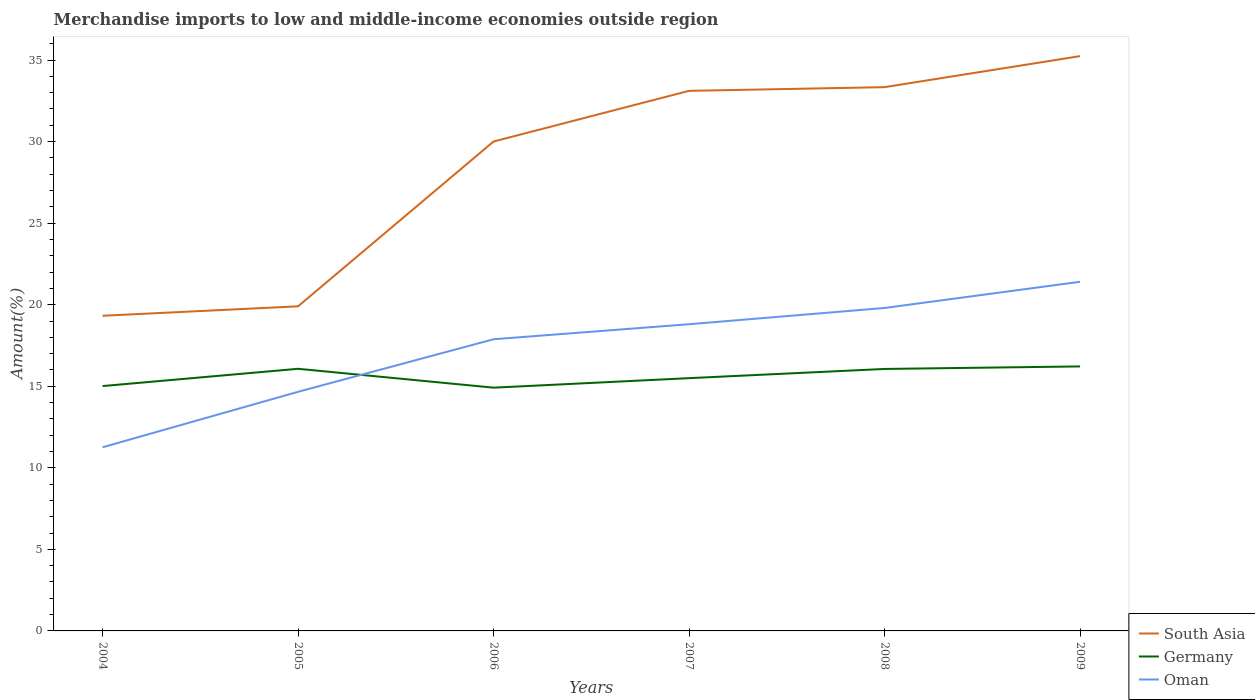Across all years, what is the maximum percentage of amount earned from merchandise imports in South Asia?
Give a very brief answer. 19.32. In which year was the percentage of amount earned from merchandise imports in Oman maximum?
Give a very brief answer. 2004. What is the total percentage of amount earned from merchandise imports in Germany in the graph?
Provide a short and direct response. 0.1. What is the difference between the highest and the second highest percentage of amount earned from merchandise imports in Oman?
Provide a short and direct response. 10.15. What is the difference between the highest and the lowest percentage of amount earned from merchandise imports in Germany?
Give a very brief answer. 3. What is the difference between two consecutive major ticks on the Y-axis?
Ensure brevity in your answer.  5. Does the graph contain any zero values?
Keep it short and to the point. No. Does the graph contain grids?
Your response must be concise. No. How many legend labels are there?
Offer a very short reply. 3. How are the legend labels stacked?
Give a very brief answer. Vertical. What is the title of the graph?
Your answer should be compact. Merchandise imports to low and middle-income economies outside region. What is the label or title of the X-axis?
Make the answer very short. Years. What is the label or title of the Y-axis?
Offer a terse response. Amount(%). What is the Amount(%) in South Asia in 2004?
Keep it short and to the point. 19.32. What is the Amount(%) in Germany in 2004?
Your answer should be very brief. 15.01. What is the Amount(%) of Oman in 2004?
Your answer should be very brief. 11.26. What is the Amount(%) in South Asia in 2005?
Give a very brief answer. 19.9. What is the Amount(%) of Germany in 2005?
Offer a very short reply. 16.07. What is the Amount(%) of Oman in 2005?
Keep it short and to the point. 14.66. What is the Amount(%) in South Asia in 2006?
Your response must be concise. 30.01. What is the Amount(%) of Germany in 2006?
Your response must be concise. 14.91. What is the Amount(%) in Oman in 2006?
Provide a short and direct response. 17.88. What is the Amount(%) in South Asia in 2007?
Make the answer very short. 33.11. What is the Amount(%) in Germany in 2007?
Ensure brevity in your answer.  15.5. What is the Amount(%) of Oman in 2007?
Give a very brief answer. 18.8. What is the Amount(%) in South Asia in 2008?
Provide a succinct answer. 33.34. What is the Amount(%) in Germany in 2008?
Your answer should be very brief. 16.06. What is the Amount(%) of Oman in 2008?
Offer a terse response. 19.8. What is the Amount(%) of South Asia in 2009?
Offer a terse response. 35.24. What is the Amount(%) in Germany in 2009?
Make the answer very short. 16.22. What is the Amount(%) of Oman in 2009?
Provide a succinct answer. 21.41. Across all years, what is the maximum Amount(%) of South Asia?
Ensure brevity in your answer.  35.24. Across all years, what is the maximum Amount(%) of Germany?
Keep it short and to the point. 16.22. Across all years, what is the maximum Amount(%) in Oman?
Keep it short and to the point. 21.41. Across all years, what is the minimum Amount(%) of South Asia?
Keep it short and to the point. 19.32. Across all years, what is the minimum Amount(%) in Germany?
Your response must be concise. 14.91. Across all years, what is the minimum Amount(%) of Oman?
Make the answer very short. 11.26. What is the total Amount(%) in South Asia in the graph?
Give a very brief answer. 170.92. What is the total Amount(%) of Germany in the graph?
Ensure brevity in your answer.  93.77. What is the total Amount(%) in Oman in the graph?
Offer a very short reply. 103.81. What is the difference between the Amount(%) in South Asia in 2004 and that in 2005?
Provide a short and direct response. -0.58. What is the difference between the Amount(%) of Germany in 2004 and that in 2005?
Keep it short and to the point. -1.06. What is the difference between the Amount(%) in Oman in 2004 and that in 2005?
Keep it short and to the point. -3.4. What is the difference between the Amount(%) of South Asia in 2004 and that in 2006?
Provide a succinct answer. -10.68. What is the difference between the Amount(%) of Germany in 2004 and that in 2006?
Ensure brevity in your answer.  0.1. What is the difference between the Amount(%) in Oman in 2004 and that in 2006?
Offer a very short reply. -6.62. What is the difference between the Amount(%) in South Asia in 2004 and that in 2007?
Give a very brief answer. -13.79. What is the difference between the Amount(%) of Germany in 2004 and that in 2007?
Your response must be concise. -0.49. What is the difference between the Amount(%) in Oman in 2004 and that in 2007?
Offer a very short reply. -7.54. What is the difference between the Amount(%) of South Asia in 2004 and that in 2008?
Your response must be concise. -14.02. What is the difference between the Amount(%) in Germany in 2004 and that in 2008?
Provide a succinct answer. -1.05. What is the difference between the Amount(%) in Oman in 2004 and that in 2008?
Your answer should be compact. -8.54. What is the difference between the Amount(%) in South Asia in 2004 and that in 2009?
Provide a short and direct response. -15.92. What is the difference between the Amount(%) of Germany in 2004 and that in 2009?
Your answer should be very brief. -1.2. What is the difference between the Amount(%) in Oman in 2004 and that in 2009?
Keep it short and to the point. -10.15. What is the difference between the Amount(%) in South Asia in 2005 and that in 2006?
Your answer should be compact. -10.1. What is the difference between the Amount(%) of Germany in 2005 and that in 2006?
Provide a succinct answer. 1.16. What is the difference between the Amount(%) of Oman in 2005 and that in 2006?
Provide a succinct answer. -3.22. What is the difference between the Amount(%) in South Asia in 2005 and that in 2007?
Your response must be concise. -13.21. What is the difference between the Amount(%) in Germany in 2005 and that in 2007?
Make the answer very short. 0.57. What is the difference between the Amount(%) of Oman in 2005 and that in 2007?
Your answer should be very brief. -4.14. What is the difference between the Amount(%) in South Asia in 2005 and that in 2008?
Your answer should be compact. -13.44. What is the difference between the Amount(%) of Germany in 2005 and that in 2008?
Provide a succinct answer. 0.01. What is the difference between the Amount(%) of Oman in 2005 and that in 2008?
Your answer should be compact. -5.14. What is the difference between the Amount(%) of South Asia in 2005 and that in 2009?
Keep it short and to the point. -15.34. What is the difference between the Amount(%) of Germany in 2005 and that in 2009?
Ensure brevity in your answer.  -0.15. What is the difference between the Amount(%) of Oman in 2005 and that in 2009?
Your response must be concise. -6.74. What is the difference between the Amount(%) in South Asia in 2006 and that in 2007?
Offer a terse response. -3.11. What is the difference between the Amount(%) in Germany in 2006 and that in 2007?
Give a very brief answer. -0.58. What is the difference between the Amount(%) of Oman in 2006 and that in 2007?
Provide a succinct answer. -0.92. What is the difference between the Amount(%) in South Asia in 2006 and that in 2008?
Provide a short and direct response. -3.33. What is the difference between the Amount(%) in Germany in 2006 and that in 2008?
Your response must be concise. -1.15. What is the difference between the Amount(%) in Oman in 2006 and that in 2008?
Your response must be concise. -1.92. What is the difference between the Amount(%) in South Asia in 2006 and that in 2009?
Offer a terse response. -5.24. What is the difference between the Amount(%) of Germany in 2006 and that in 2009?
Your answer should be very brief. -1.3. What is the difference between the Amount(%) of Oman in 2006 and that in 2009?
Offer a terse response. -3.52. What is the difference between the Amount(%) of South Asia in 2007 and that in 2008?
Ensure brevity in your answer.  -0.23. What is the difference between the Amount(%) of Germany in 2007 and that in 2008?
Give a very brief answer. -0.56. What is the difference between the Amount(%) of Oman in 2007 and that in 2008?
Your answer should be very brief. -1. What is the difference between the Amount(%) in South Asia in 2007 and that in 2009?
Provide a succinct answer. -2.13. What is the difference between the Amount(%) in Germany in 2007 and that in 2009?
Your response must be concise. -0.72. What is the difference between the Amount(%) of Oman in 2007 and that in 2009?
Offer a very short reply. -2.6. What is the difference between the Amount(%) in South Asia in 2008 and that in 2009?
Offer a very short reply. -1.9. What is the difference between the Amount(%) in Germany in 2008 and that in 2009?
Offer a terse response. -0.16. What is the difference between the Amount(%) in Oman in 2008 and that in 2009?
Offer a very short reply. -1.61. What is the difference between the Amount(%) of South Asia in 2004 and the Amount(%) of Germany in 2005?
Your answer should be compact. 3.25. What is the difference between the Amount(%) of South Asia in 2004 and the Amount(%) of Oman in 2005?
Keep it short and to the point. 4.66. What is the difference between the Amount(%) of Germany in 2004 and the Amount(%) of Oman in 2005?
Offer a terse response. 0.35. What is the difference between the Amount(%) in South Asia in 2004 and the Amount(%) in Germany in 2006?
Your answer should be very brief. 4.41. What is the difference between the Amount(%) in South Asia in 2004 and the Amount(%) in Oman in 2006?
Provide a succinct answer. 1.44. What is the difference between the Amount(%) of Germany in 2004 and the Amount(%) of Oman in 2006?
Provide a succinct answer. -2.87. What is the difference between the Amount(%) in South Asia in 2004 and the Amount(%) in Germany in 2007?
Offer a terse response. 3.83. What is the difference between the Amount(%) of South Asia in 2004 and the Amount(%) of Oman in 2007?
Your answer should be compact. 0.52. What is the difference between the Amount(%) in Germany in 2004 and the Amount(%) in Oman in 2007?
Offer a terse response. -3.79. What is the difference between the Amount(%) in South Asia in 2004 and the Amount(%) in Germany in 2008?
Provide a succinct answer. 3.26. What is the difference between the Amount(%) in South Asia in 2004 and the Amount(%) in Oman in 2008?
Offer a terse response. -0.48. What is the difference between the Amount(%) in Germany in 2004 and the Amount(%) in Oman in 2008?
Ensure brevity in your answer.  -4.79. What is the difference between the Amount(%) of South Asia in 2004 and the Amount(%) of Germany in 2009?
Your response must be concise. 3.11. What is the difference between the Amount(%) of South Asia in 2004 and the Amount(%) of Oman in 2009?
Your answer should be very brief. -2.08. What is the difference between the Amount(%) in Germany in 2004 and the Amount(%) in Oman in 2009?
Your answer should be very brief. -6.39. What is the difference between the Amount(%) in South Asia in 2005 and the Amount(%) in Germany in 2006?
Give a very brief answer. 4.99. What is the difference between the Amount(%) of South Asia in 2005 and the Amount(%) of Oman in 2006?
Offer a very short reply. 2.02. What is the difference between the Amount(%) in Germany in 2005 and the Amount(%) in Oman in 2006?
Your answer should be compact. -1.81. What is the difference between the Amount(%) of South Asia in 2005 and the Amount(%) of Germany in 2007?
Make the answer very short. 4.4. What is the difference between the Amount(%) of South Asia in 2005 and the Amount(%) of Oman in 2007?
Provide a short and direct response. 1.1. What is the difference between the Amount(%) in Germany in 2005 and the Amount(%) in Oman in 2007?
Keep it short and to the point. -2.73. What is the difference between the Amount(%) of South Asia in 2005 and the Amount(%) of Germany in 2008?
Keep it short and to the point. 3.84. What is the difference between the Amount(%) in South Asia in 2005 and the Amount(%) in Oman in 2008?
Give a very brief answer. 0.1. What is the difference between the Amount(%) of Germany in 2005 and the Amount(%) of Oman in 2008?
Offer a very short reply. -3.73. What is the difference between the Amount(%) of South Asia in 2005 and the Amount(%) of Germany in 2009?
Keep it short and to the point. 3.68. What is the difference between the Amount(%) in South Asia in 2005 and the Amount(%) in Oman in 2009?
Give a very brief answer. -1.5. What is the difference between the Amount(%) of Germany in 2005 and the Amount(%) of Oman in 2009?
Give a very brief answer. -5.33. What is the difference between the Amount(%) in South Asia in 2006 and the Amount(%) in Germany in 2007?
Your answer should be compact. 14.51. What is the difference between the Amount(%) in South Asia in 2006 and the Amount(%) in Oman in 2007?
Offer a very short reply. 11.2. What is the difference between the Amount(%) of Germany in 2006 and the Amount(%) of Oman in 2007?
Offer a very short reply. -3.89. What is the difference between the Amount(%) of South Asia in 2006 and the Amount(%) of Germany in 2008?
Ensure brevity in your answer.  13.94. What is the difference between the Amount(%) in South Asia in 2006 and the Amount(%) in Oman in 2008?
Give a very brief answer. 10.21. What is the difference between the Amount(%) in Germany in 2006 and the Amount(%) in Oman in 2008?
Your response must be concise. -4.89. What is the difference between the Amount(%) in South Asia in 2006 and the Amount(%) in Germany in 2009?
Provide a short and direct response. 13.79. What is the difference between the Amount(%) of South Asia in 2006 and the Amount(%) of Oman in 2009?
Offer a very short reply. 8.6. What is the difference between the Amount(%) in Germany in 2006 and the Amount(%) in Oman in 2009?
Your answer should be compact. -6.49. What is the difference between the Amount(%) in South Asia in 2007 and the Amount(%) in Germany in 2008?
Provide a short and direct response. 17.05. What is the difference between the Amount(%) in South Asia in 2007 and the Amount(%) in Oman in 2008?
Ensure brevity in your answer.  13.31. What is the difference between the Amount(%) in Germany in 2007 and the Amount(%) in Oman in 2008?
Give a very brief answer. -4.3. What is the difference between the Amount(%) in South Asia in 2007 and the Amount(%) in Germany in 2009?
Offer a terse response. 16.9. What is the difference between the Amount(%) in South Asia in 2007 and the Amount(%) in Oman in 2009?
Ensure brevity in your answer.  11.71. What is the difference between the Amount(%) in Germany in 2007 and the Amount(%) in Oman in 2009?
Offer a terse response. -5.91. What is the difference between the Amount(%) in South Asia in 2008 and the Amount(%) in Germany in 2009?
Make the answer very short. 17.12. What is the difference between the Amount(%) of South Asia in 2008 and the Amount(%) of Oman in 2009?
Your answer should be compact. 11.93. What is the difference between the Amount(%) of Germany in 2008 and the Amount(%) of Oman in 2009?
Make the answer very short. -5.34. What is the average Amount(%) of South Asia per year?
Ensure brevity in your answer.  28.49. What is the average Amount(%) in Germany per year?
Offer a terse response. 15.63. What is the average Amount(%) in Oman per year?
Offer a terse response. 17.3. In the year 2004, what is the difference between the Amount(%) of South Asia and Amount(%) of Germany?
Your answer should be compact. 4.31. In the year 2004, what is the difference between the Amount(%) of South Asia and Amount(%) of Oman?
Keep it short and to the point. 8.06. In the year 2004, what is the difference between the Amount(%) in Germany and Amount(%) in Oman?
Make the answer very short. 3.75. In the year 2005, what is the difference between the Amount(%) in South Asia and Amount(%) in Germany?
Provide a short and direct response. 3.83. In the year 2005, what is the difference between the Amount(%) in South Asia and Amount(%) in Oman?
Give a very brief answer. 5.24. In the year 2005, what is the difference between the Amount(%) of Germany and Amount(%) of Oman?
Provide a succinct answer. 1.41. In the year 2006, what is the difference between the Amount(%) in South Asia and Amount(%) in Germany?
Your answer should be compact. 15.09. In the year 2006, what is the difference between the Amount(%) of South Asia and Amount(%) of Oman?
Provide a succinct answer. 12.12. In the year 2006, what is the difference between the Amount(%) of Germany and Amount(%) of Oman?
Provide a short and direct response. -2.97. In the year 2007, what is the difference between the Amount(%) of South Asia and Amount(%) of Germany?
Your answer should be compact. 17.62. In the year 2007, what is the difference between the Amount(%) in South Asia and Amount(%) in Oman?
Your answer should be compact. 14.31. In the year 2007, what is the difference between the Amount(%) in Germany and Amount(%) in Oman?
Provide a succinct answer. -3.31. In the year 2008, what is the difference between the Amount(%) in South Asia and Amount(%) in Germany?
Offer a terse response. 17.28. In the year 2008, what is the difference between the Amount(%) in South Asia and Amount(%) in Oman?
Offer a very short reply. 13.54. In the year 2008, what is the difference between the Amount(%) in Germany and Amount(%) in Oman?
Offer a terse response. -3.74. In the year 2009, what is the difference between the Amount(%) in South Asia and Amount(%) in Germany?
Your answer should be very brief. 19.02. In the year 2009, what is the difference between the Amount(%) of South Asia and Amount(%) of Oman?
Your response must be concise. 13.84. In the year 2009, what is the difference between the Amount(%) of Germany and Amount(%) of Oman?
Your answer should be very brief. -5.19. What is the ratio of the Amount(%) of South Asia in 2004 to that in 2005?
Offer a terse response. 0.97. What is the ratio of the Amount(%) in Germany in 2004 to that in 2005?
Ensure brevity in your answer.  0.93. What is the ratio of the Amount(%) in Oman in 2004 to that in 2005?
Your response must be concise. 0.77. What is the ratio of the Amount(%) in South Asia in 2004 to that in 2006?
Your response must be concise. 0.64. What is the ratio of the Amount(%) in Germany in 2004 to that in 2006?
Ensure brevity in your answer.  1.01. What is the ratio of the Amount(%) of Oman in 2004 to that in 2006?
Ensure brevity in your answer.  0.63. What is the ratio of the Amount(%) in South Asia in 2004 to that in 2007?
Your response must be concise. 0.58. What is the ratio of the Amount(%) in Germany in 2004 to that in 2007?
Your answer should be compact. 0.97. What is the ratio of the Amount(%) of Oman in 2004 to that in 2007?
Provide a succinct answer. 0.6. What is the ratio of the Amount(%) of South Asia in 2004 to that in 2008?
Provide a succinct answer. 0.58. What is the ratio of the Amount(%) in Germany in 2004 to that in 2008?
Keep it short and to the point. 0.93. What is the ratio of the Amount(%) in Oman in 2004 to that in 2008?
Keep it short and to the point. 0.57. What is the ratio of the Amount(%) of South Asia in 2004 to that in 2009?
Ensure brevity in your answer.  0.55. What is the ratio of the Amount(%) in Germany in 2004 to that in 2009?
Ensure brevity in your answer.  0.93. What is the ratio of the Amount(%) of Oman in 2004 to that in 2009?
Make the answer very short. 0.53. What is the ratio of the Amount(%) of South Asia in 2005 to that in 2006?
Provide a succinct answer. 0.66. What is the ratio of the Amount(%) of Germany in 2005 to that in 2006?
Keep it short and to the point. 1.08. What is the ratio of the Amount(%) in Oman in 2005 to that in 2006?
Give a very brief answer. 0.82. What is the ratio of the Amount(%) of South Asia in 2005 to that in 2007?
Offer a terse response. 0.6. What is the ratio of the Amount(%) in Oman in 2005 to that in 2007?
Provide a succinct answer. 0.78. What is the ratio of the Amount(%) in South Asia in 2005 to that in 2008?
Offer a very short reply. 0.6. What is the ratio of the Amount(%) in Oman in 2005 to that in 2008?
Make the answer very short. 0.74. What is the ratio of the Amount(%) in South Asia in 2005 to that in 2009?
Your response must be concise. 0.56. What is the ratio of the Amount(%) in Germany in 2005 to that in 2009?
Your response must be concise. 0.99. What is the ratio of the Amount(%) of Oman in 2005 to that in 2009?
Provide a succinct answer. 0.68. What is the ratio of the Amount(%) in South Asia in 2006 to that in 2007?
Ensure brevity in your answer.  0.91. What is the ratio of the Amount(%) of Germany in 2006 to that in 2007?
Offer a terse response. 0.96. What is the ratio of the Amount(%) of Oman in 2006 to that in 2007?
Offer a terse response. 0.95. What is the ratio of the Amount(%) in Oman in 2006 to that in 2008?
Offer a very short reply. 0.9. What is the ratio of the Amount(%) in South Asia in 2006 to that in 2009?
Keep it short and to the point. 0.85. What is the ratio of the Amount(%) of Germany in 2006 to that in 2009?
Provide a short and direct response. 0.92. What is the ratio of the Amount(%) of Oman in 2006 to that in 2009?
Your response must be concise. 0.84. What is the ratio of the Amount(%) of Germany in 2007 to that in 2008?
Offer a very short reply. 0.96. What is the ratio of the Amount(%) of Oman in 2007 to that in 2008?
Offer a very short reply. 0.95. What is the ratio of the Amount(%) in South Asia in 2007 to that in 2009?
Make the answer very short. 0.94. What is the ratio of the Amount(%) of Germany in 2007 to that in 2009?
Your answer should be compact. 0.96. What is the ratio of the Amount(%) of Oman in 2007 to that in 2009?
Keep it short and to the point. 0.88. What is the ratio of the Amount(%) in South Asia in 2008 to that in 2009?
Provide a short and direct response. 0.95. What is the ratio of the Amount(%) of Oman in 2008 to that in 2009?
Keep it short and to the point. 0.93. What is the difference between the highest and the second highest Amount(%) in South Asia?
Provide a short and direct response. 1.9. What is the difference between the highest and the second highest Amount(%) in Germany?
Ensure brevity in your answer.  0.15. What is the difference between the highest and the second highest Amount(%) of Oman?
Offer a very short reply. 1.61. What is the difference between the highest and the lowest Amount(%) of South Asia?
Provide a succinct answer. 15.92. What is the difference between the highest and the lowest Amount(%) of Germany?
Your response must be concise. 1.3. What is the difference between the highest and the lowest Amount(%) in Oman?
Provide a short and direct response. 10.15. 